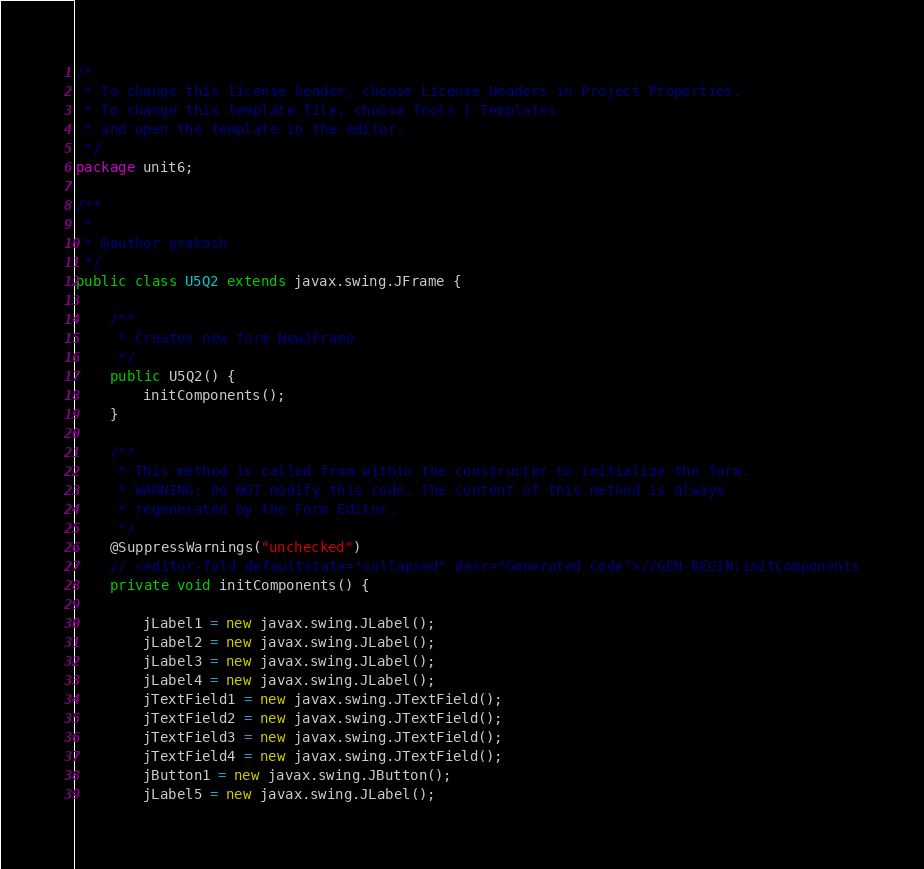<code> <loc_0><loc_0><loc_500><loc_500><_Java_>/*
 * To change this license header, choose License Headers in Project Properties.
 * To change this template file, choose Tools | Templates
 * and open the template in the editor.
 */
package unit6;

/**
 *
 * @author prakash
 */
public class U5Q2 extends javax.swing.JFrame {

    /**
     * Creates new form NewJFrame
     */
    public U5Q2() {
        initComponents();
    }

    /**
     * This method is called from within the constructor to initialize the form.
     * WARNING: Do NOT modify this code. The content of this method is always
     * regenerated by the Form Editor.
     */
    @SuppressWarnings("unchecked")
    // <editor-fold defaultstate="collapsed" desc="Generated Code">//GEN-BEGIN:initComponents
    private void initComponents() {

        jLabel1 = new javax.swing.JLabel();
        jLabel2 = new javax.swing.JLabel();
        jLabel3 = new javax.swing.JLabel();
        jLabel4 = new javax.swing.JLabel();
        jTextField1 = new javax.swing.JTextField();
        jTextField2 = new javax.swing.JTextField();
        jTextField3 = new javax.swing.JTextField();
        jTextField4 = new javax.swing.JTextField();
        jButton1 = new javax.swing.JButton();
        jLabel5 = new javax.swing.JLabel();</code> 